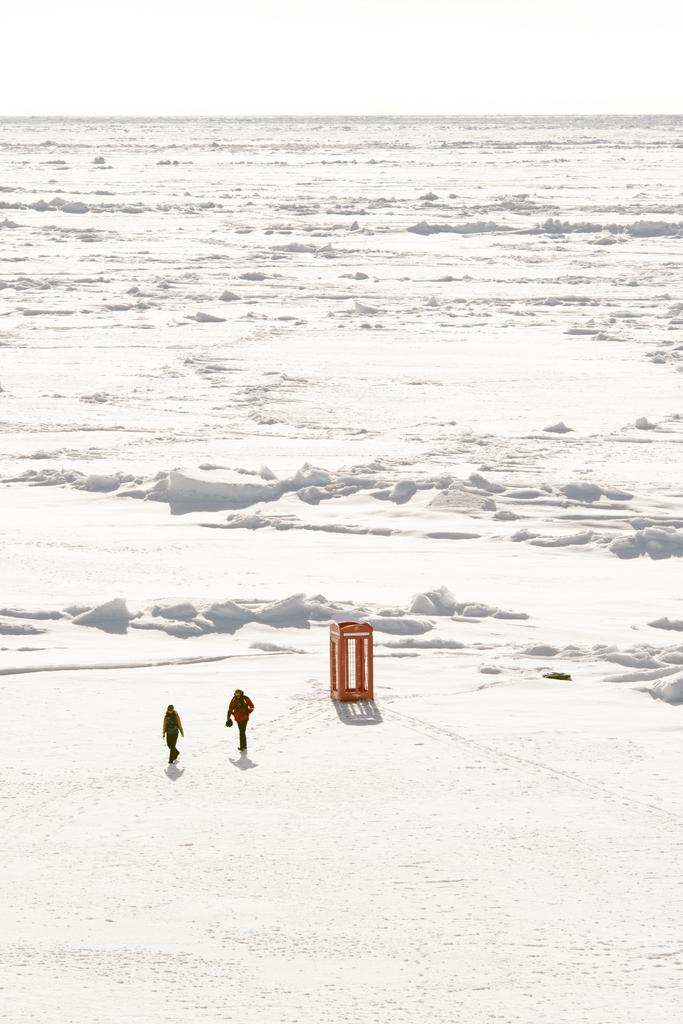What is the main feature of the image? The main feature of the image is the snow. What are the persons in the image doing? The persons in the image are on the snow. What object can be seen in the image besides the snow and persons? There is a cage in the image. What can be seen in the background of the image? The sky is visible in the background of the image. What degree of heat is being emitted from the pie in the image? There is no pie present in the image, so it is not possible to determine the degree of heat being emitted. --- Facts: 1. There is a car in the image. 2. The car is red. 3. The car has four wheels. 4. There is a road in the image. 5. The road is paved. Absurd Topics: bird, ocean, mountain Conversation: What is the main subject of the image? The main subject of the image is a car. What color is the car? The car is red. How many wheels does the car have? The car has four wheels. What is the surface of the road in the image? The road is paved. Reasoning: Let's think step by step in order to produce the conversation. We start by identifying the main subject of the image, which is the car. Then, we describe the color and number of wheels of the car. Finally, we mention the surface of the road in the image, which is paved. Absurd Question/Answer: Can you see any birds flying over the ocean in the image? There is no ocean or birds present in the image; it features a red car with four wheels on a paved road. --- Facts: 1. There is a person holding a book in the image. 2. The book is open. 3. The person is sitting on a chair. 4. There is a table in the image. 5. The table has a lamp on it. Absurd Topics: fish, volcano, rainbow Conversation: What is the person in the image holding? The person in the image is holding a book. What is the state of the book? The book is open. What is the person sitting on? The person is sitting on a chair. What object can be seen on the table in the image? There is a lamp on the table in the image. Reasoning: Let's think step by step in order to produce the conversation. We start by identifying the main subject of the image, which is the person holding a book. Then, we describe the state of the book, noting that it is open. Next, we mention the person's seating arrangement, which is on a chair. Finally, we mention the presence of a lamp on the table in 